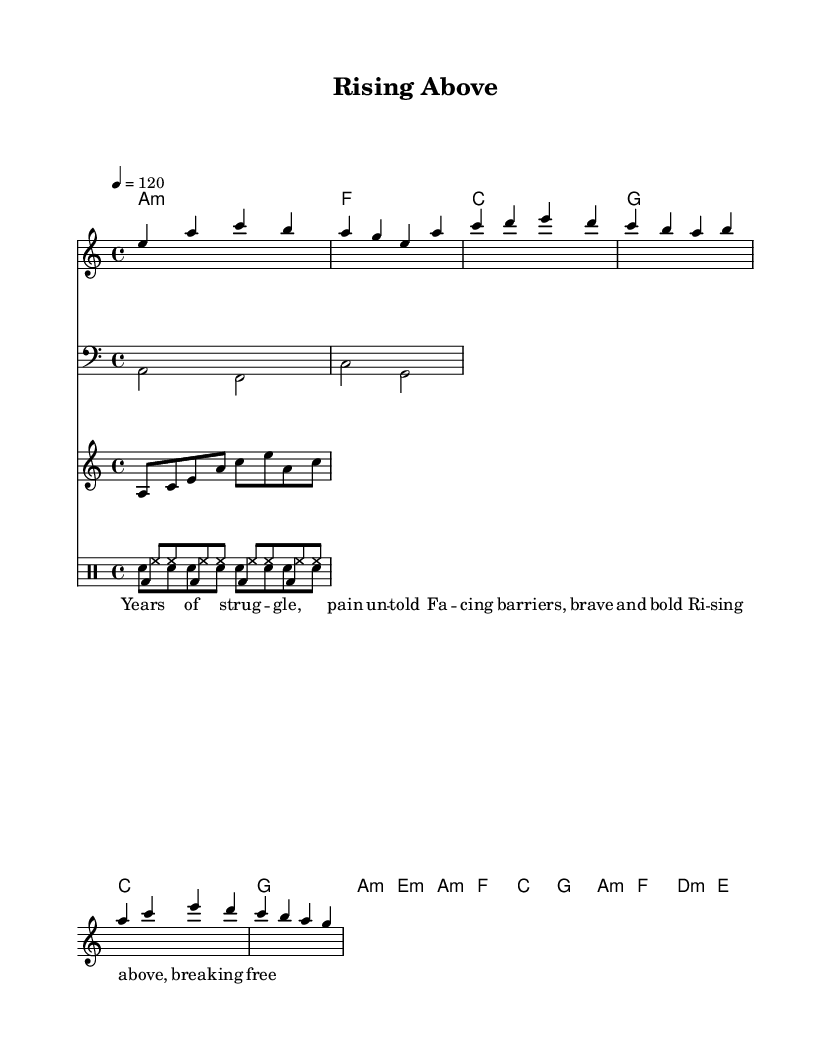What is the key signature of this music? The key signature is A minor, which has no sharps or flats.
Answer: A minor What is the time signature of the piece? The time signature is indicated in the music as 4/4, meaning there are four beats in each measure and the quarter note gets one beat.
Answer: 4/4 What is the tempo marking provided? The tempo marking shows 4 equals 120, which indicates that the piece should be played at 120 beats per minute.
Answer: 120 How many measures are there in the chorus section? To find this, we look at the chord mode and melody; the chorus consists of two measures of lyrical content.
Answer: 2 Why is the bass line written in the bass clef? The bass line is written in the bass clef because it typically contains notes that are lower in pitch, which is standard for bass instruments.
Answer: Bass clef What type of drum pattern is used in this composition? The composition incorporates a basic four-on-the-floor kick drum pattern, consisting of a bass drum hit on each beat, typical in electronic dance music.
Answer: Four-on-the-floor Which instrument provides the arpeggiator pattern? The arpeggiator pattern is typically played by a synthesizer in electronic music, providing a rhythmic and harmonic texture that complements the lead melody.
Answer: Synthesizer 